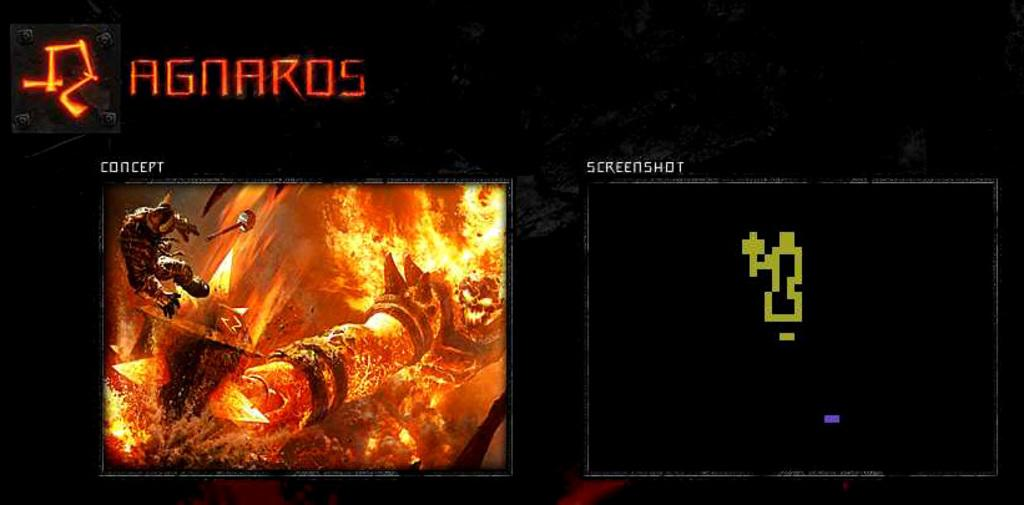Provide a one-sentence caption for the provided image. The concept is much more detailed than the screenshot. 